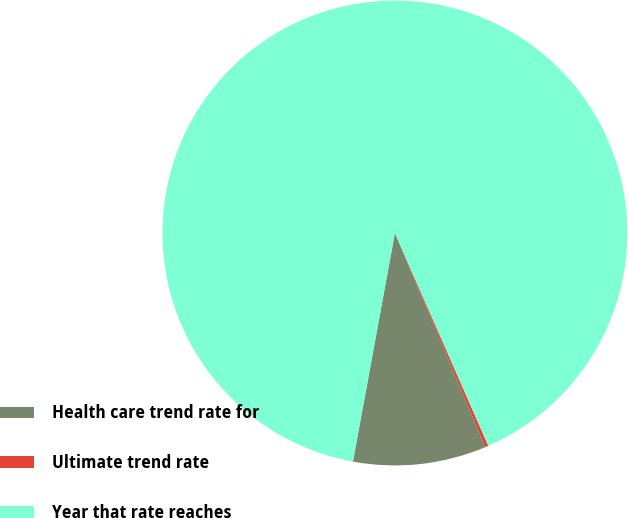<chart> <loc_0><loc_0><loc_500><loc_500><pie_chart><fcel>Health care trend rate for<fcel>Ultimate trend rate<fcel>Year that rate reaches<nl><fcel>9.25%<fcel>0.22%<fcel>90.52%<nl></chart> 